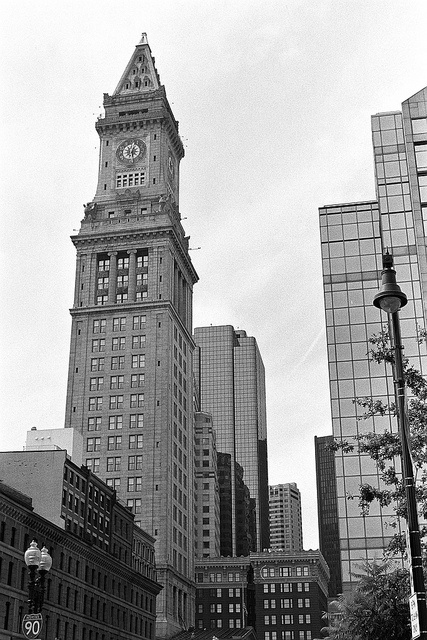Describe the objects in this image and their specific colors. I can see clock in white, gray, darkgray, lightgray, and black tones and clock in white, gray, darkgray, black, and silver tones in this image. 